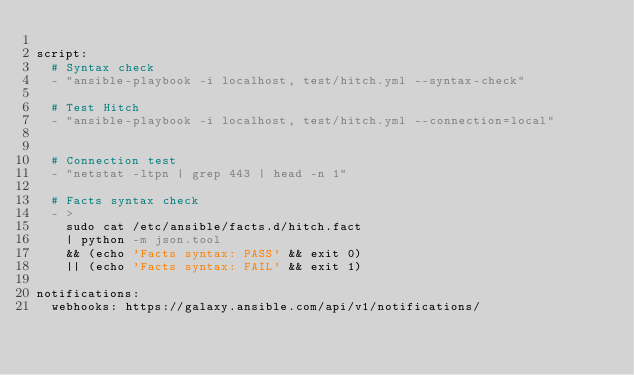<code> <loc_0><loc_0><loc_500><loc_500><_YAML_>
script:
  # Syntax check
  - "ansible-playbook -i localhost, test/hitch.yml --syntax-check"

  # Test Hitch
  - "ansible-playbook -i localhost, test/hitch.yml --connection=local"


  # Connection test
  - "netstat -ltpn | grep 443 | head -n 1"

  # Facts syntax check
  - >
    sudo cat /etc/ansible/facts.d/hitch.fact
    | python -m json.tool
    && (echo 'Facts syntax: PASS' && exit 0)
    || (echo 'Facts syntax: FAIL' && exit 1)

notifications:
  webhooks: https://galaxy.ansible.com/api/v1/notifications/
</code> 